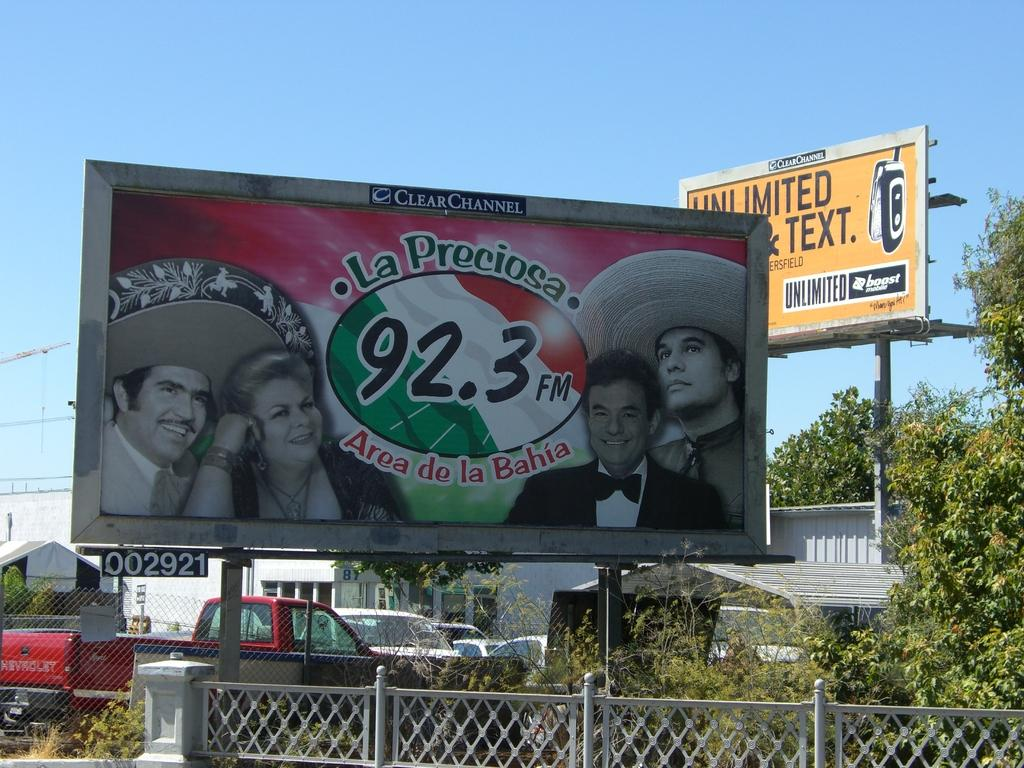<image>
Describe the image concisely. A billboard for La Preciosa can be seen next to the fenced parking lot. 